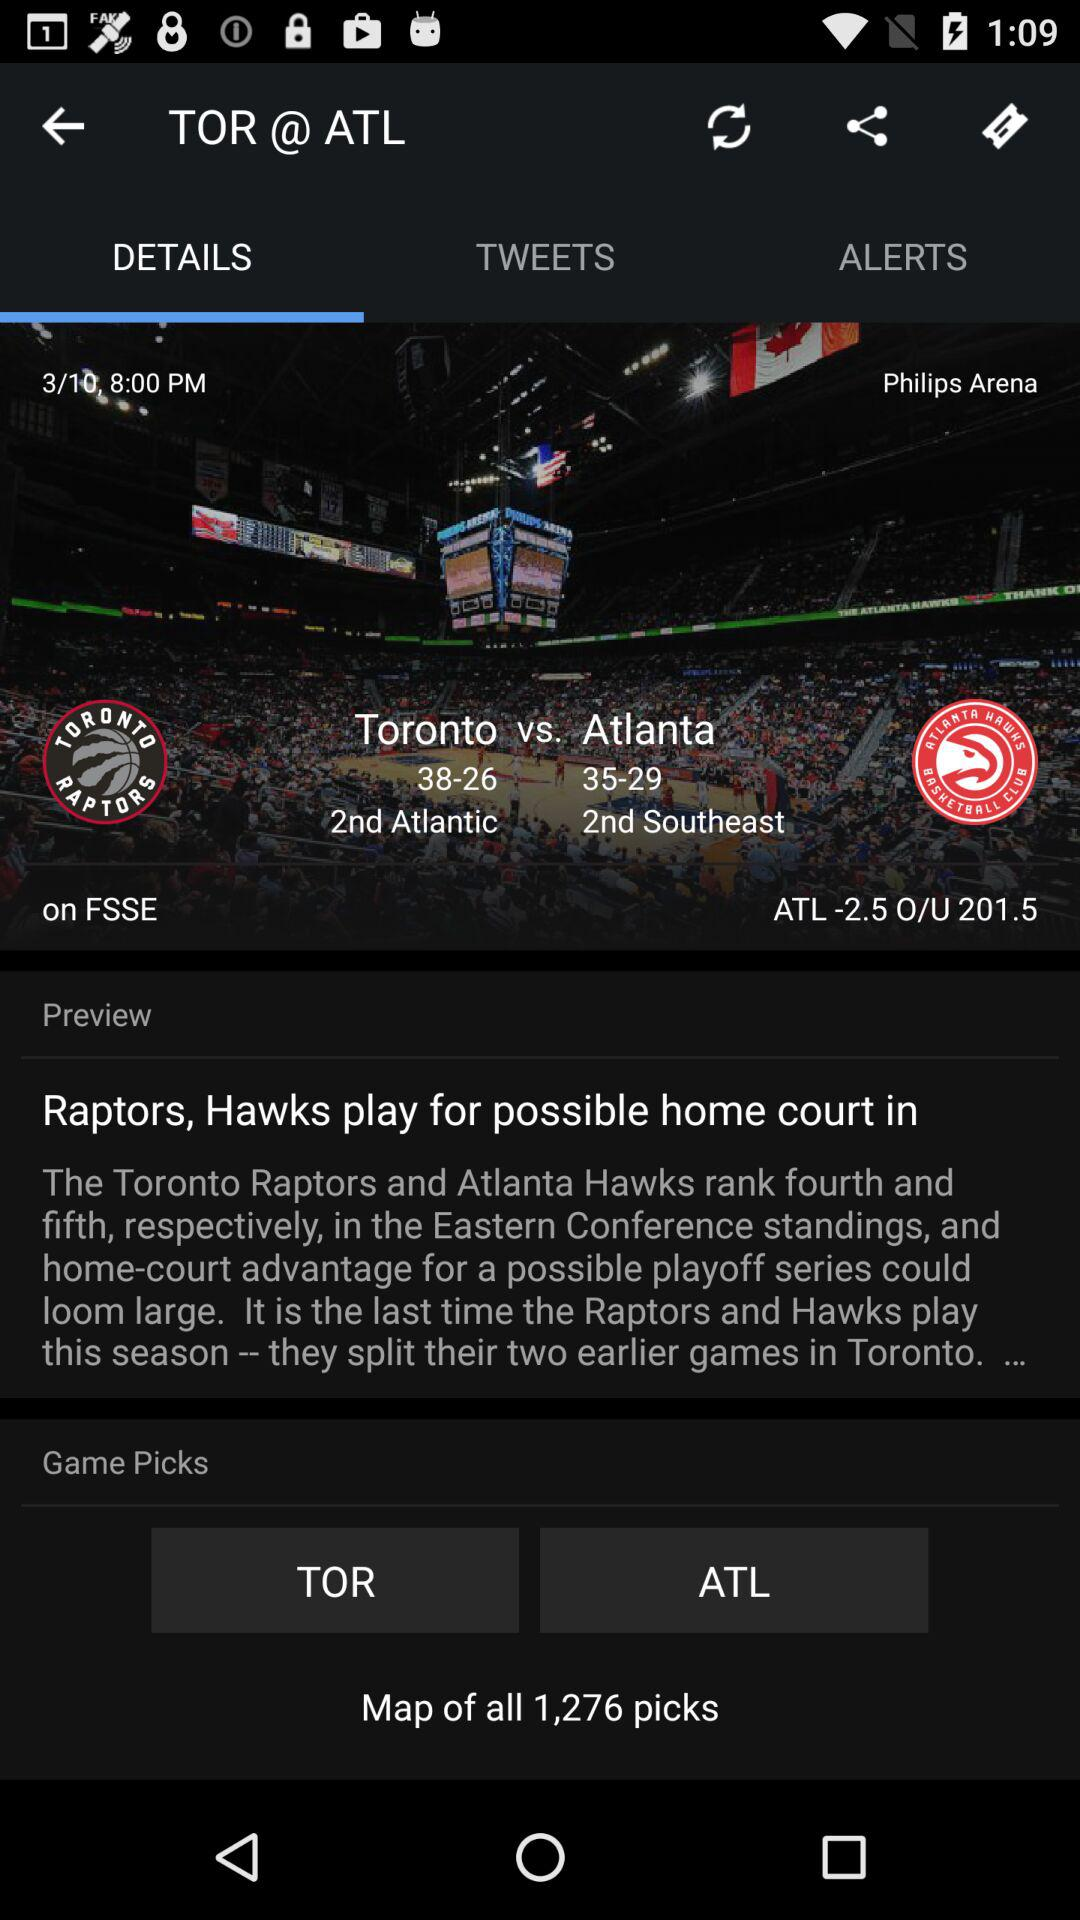What is the rank of the "Toronto Raptors"? The rank of the "Toronto raptors" is fourth. 